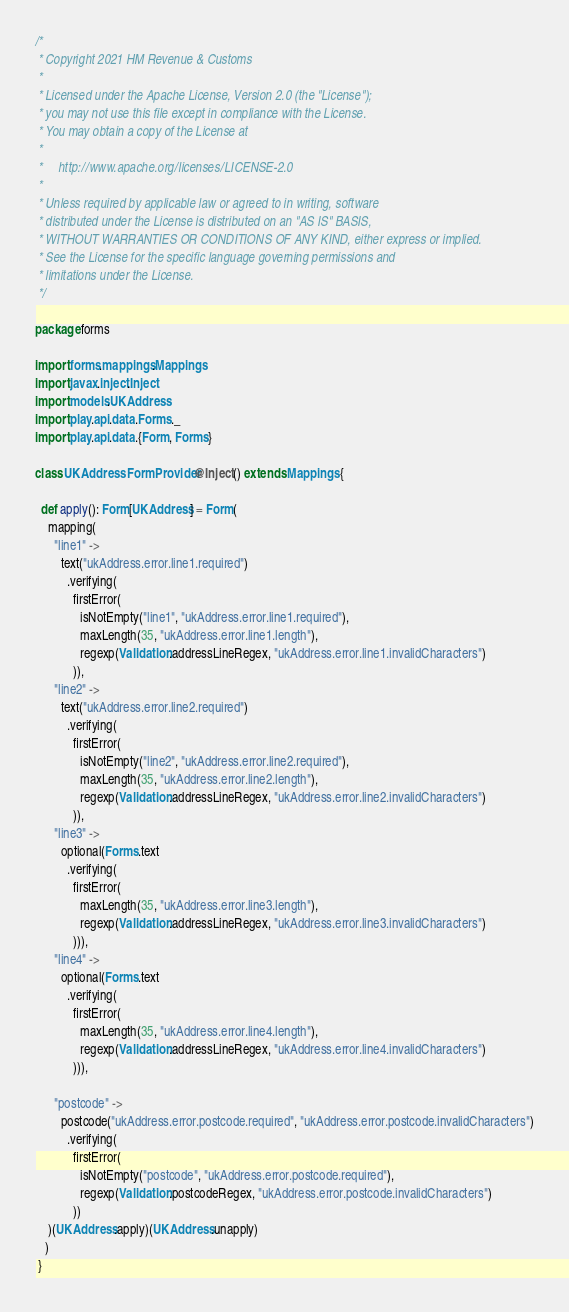Convert code to text. <code><loc_0><loc_0><loc_500><loc_500><_Scala_>/*
 * Copyright 2021 HM Revenue & Customs
 *
 * Licensed under the Apache License, Version 2.0 (the "License");
 * you may not use this file except in compliance with the License.
 * You may obtain a copy of the License at
 *
 *     http://www.apache.org/licenses/LICENSE-2.0
 *
 * Unless required by applicable law or agreed to in writing, software
 * distributed under the License is distributed on an "AS IS" BASIS,
 * WITHOUT WARRANTIES OR CONDITIONS OF ANY KIND, either express or implied.
 * See the License for the specific language governing permissions and
 * limitations under the License.
 */

package forms

import forms.mappings.Mappings
import javax.inject.Inject
import models.UKAddress
import play.api.data.Forms._
import play.api.data.{Form, Forms}

class UKAddressFormProvider @Inject() extends Mappings {

  def apply(): Form[UKAddress] = Form(
    mapping(
      "line1" ->
        text("ukAddress.error.line1.required")
          .verifying(
            firstError(
              isNotEmpty("line1", "ukAddress.error.line1.required"),
              maxLength(35, "ukAddress.error.line1.length"),
              regexp(Validation.addressLineRegex, "ukAddress.error.line1.invalidCharacters")
            )),
      "line2" ->
        text("ukAddress.error.line2.required")
          .verifying(
            firstError(
              isNotEmpty("line2", "ukAddress.error.line2.required"),
              maxLength(35, "ukAddress.error.line2.length"),
              regexp(Validation.addressLineRegex, "ukAddress.error.line2.invalidCharacters")
            )),
      "line3" ->
        optional(Forms.text
          .verifying(
            firstError(
              maxLength(35, "ukAddress.error.line3.length"),
              regexp(Validation.addressLineRegex, "ukAddress.error.line3.invalidCharacters")
            ))),
      "line4" ->
        optional(Forms.text
          .verifying(
            firstError(
              maxLength(35, "ukAddress.error.line4.length"),
              regexp(Validation.addressLineRegex, "ukAddress.error.line4.invalidCharacters")
            ))),

      "postcode" ->
        postcode("ukAddress.error.postcode.required", "ukAddress.error.postcode.invalidCharacters")
          .verifying(
            firstError(
              isNotEmpty("postcode", "ukAddress.error.postcode.required"),
              regexp(Validation.postcodeRegex, "ukAddress.error.postcode.invalidCharacters")
            ))
    )(UKAddress.apply)(UKAddress.unapply)
   )
 }
</code> 